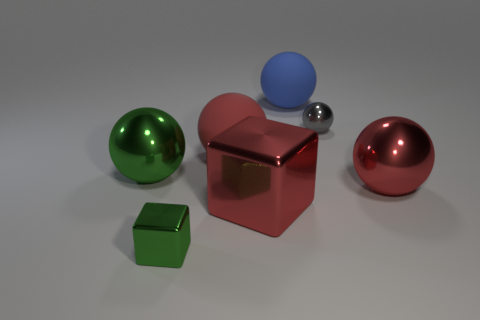How many big things are in front of the blue thing?
Keep it short and to the point. 4. Is there a brown shiny cylinder?
Provide a short and direct response. No. There is a metallic block that is right of the red sphere that is on the left side of the large thing to the right of the small gray ball; what size is it?
Your response must be concise. Large. How many other things are there of the same size as the red matte ball?
Ensure brevity in your answer.  4. What size is the metal thing in front of the large red block?
Ensure brevity in your answer.  Small. Is there anything else of the same color as the tiny shiny sphere?
Make the answer very short. No. Are the small thing to the right of the large cube and the red block made of the same material?
Keep it short and to the point. Yes. How many objects are both to the right of the tiny metallic block and behind the large red block?
Provide a succinct answer. 4. What is the size of the metallic ball on the left side of the small metallic object that is to the right of the red matte sphere?
Make the answer very short. Large. Are there any other things that are made of the same material as the tiny gray object?
Offer a terse response. Yes. 